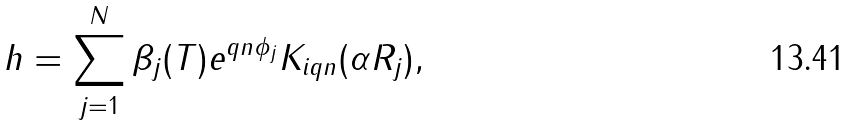Convert formula to latex. <formula><loc_0><loc_0><loc_500><loc_500>h = \sum _ { j = 1 } ^ { N } \beta _ { j } ( T ) e ^ { q n \phi _ { j } } K _ { i q n } ( \alpha R _ { j } ) ,</formula> 